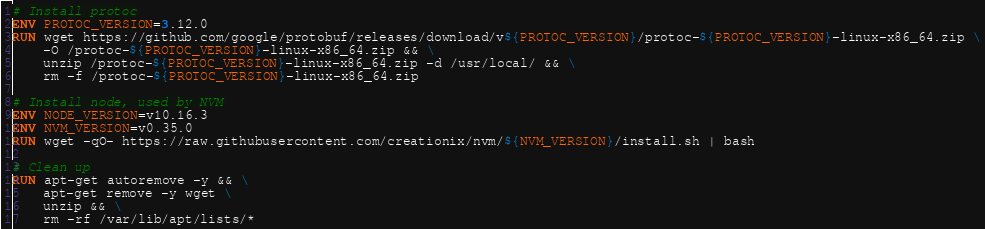Convert code to text. <code><loc_0><loc_0><loc_500><loc_500><_Dockerfile_>
# Install protoc
ENV PROTOC_VERSION=3.12.0
RUN wget https://github.com/google/protobuf/releases/download/v${PROTOC_VERSION}/protoc-${PROTOC_VERSION}-linux-x86_64.zip \
    -O /protoc-${PROTOC_VERSION}-linux-x86_64.zip && \
    unzip /protoc-${PROTOC_VERSION}-linux-x86_64.zip -d /usr/local/ && \
    rm -f /protoc-${PROTOC_VERSION}-linux-x86_64.zip

# Install node, used by NVM
ENV NODE_VERSION=v10.16.3
ENV NVM_VERSION=v0.35.0
RUN wget -qO- https://raw.githubusercontent.com/creationix/nvm/${NVM_VERSION}/install.sh | bash

# Clean up
RUN apt-get autoremove -y && \
    apt-get remove -y wget \
    unzip && \
    rm -rf /var/lib/apt/lists/*
</code> 